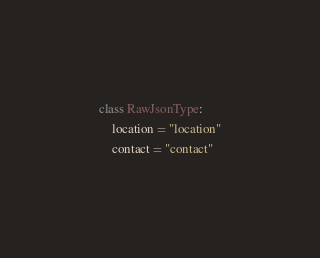Convert code to text. <code><loc_0><loc_0><loc_500><loc_500><_Python_>class RawJsonType:
    location = "location"
    contact = "contact"
</code> 